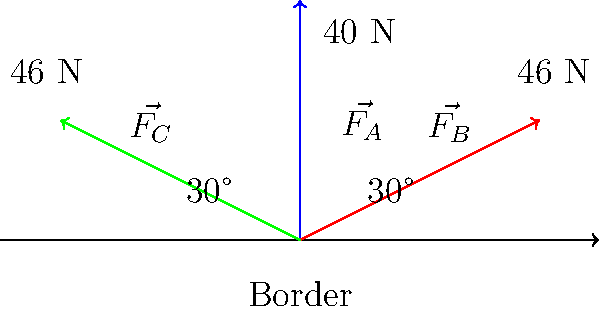In a border dispute between three countries A, B, and C, the forces exerted by each country are represented by vectors $\vec{F_A}$, $\vec{F_B}$, and $\vec{F_C}$ respectively, as shown in the free-body diagram. $\vec{F_A}$ has a magnitude of 40 N and is perpendicular to the border. Both $\vec{F_B}$ and $\vec{F_C}$ have magnitudes of 46 N and form 30° angles with the border in opposite directions. Calculate the net force along the border (x-axis) and determine which country's influence is dominant in this direction. To solve this problem, we need to follow these steps:

1) Decompose the forces into their x and y components:

   $\vec{F_A}$: No x-component (perpendicular to border)
   $F_{Ax} = 0$ N
   $F_{Ay} = 40$ N

   $\vec{F_B}$: $F_{Bx} = 46 \cos(30°)$ N, $F_{By} = 46 \sin(30°)$ N
   $F_{Bx} = 46 \cdot \frac{\sqrt{3}}{2} = 39.84$ N
   $F_{By} = 46 \cdot \frac{1}{2} = 23$ N

   $\vec{F_C}$: $F_{Cx} = -46 \cos(30°)$ N, $F_{Cy} = 46 \sin(30°)$ N
   $F_{Cx} = -39.84$ N
   $F_{Cy} = 23$ N

2) Sum the x-components to find the net force along the border:

   $F_{net,x} = F_{Ax} + F_{Bx} + F_{Cx}$
   $F_{net,x} = 0 + 39.84 - 39.84 = 0$ N

3) Interpret the result:
   The net force along the border is zero, indicating that the influences of countries B and C cancel each other out in this direction. Country A's influence is perpendicular to the border and doesn't contribute to the x-component.
Answer: Net force along border: 0 N. No country's influence is dominant in this direction. 